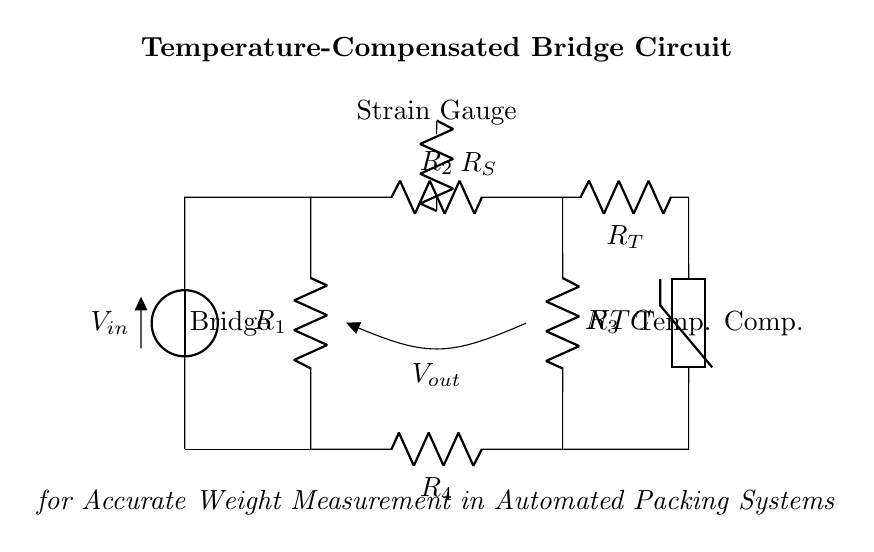What components are in the bridge circuit? The bridge circuit includes resistors R1, R2, R3, and R4, as well as a voltage source, a strain gauge, and a temperature compensation circuit with a thermistor (NTC).
Answer: R1, R2, R3, R4, voltage source, strain gauge, thermistor What type of strain measurement does this circuit utilize? The circuit utilizes a strain gauge for measuring mechanical strain. This component is specifically designed to detect changes in resistance due to applied mechanical stress, thus affecting the output voltage.
Answer: Strain gauge What is the purpose of the thermistor in the circuit? The thermistor is used for temperature compensation to ensure that the weight measurement remains accurate despite temperature variations, as changes in temperature can affect the resistance of the strain gauge.
Answer: Temperature compensation Which component connects to the output voltage? The output voltage is connected between the midpoints of the resistive bridge formed by R1, R2, R3, and R4, specifically where the strain gauge affects the bridge balance.
Answer: Strain gauge How does the temperature compensation circuit affect the measurement? The temperature compensation circuit adjusts the resistance of R_T and the thermistor in response to temperature changes, thereby stabilizing the bridge's output voltage and ensuring consistent weight measurements regardless of temperature fluctuations.
Answer: Stabilizes output What is the expected output voltage when the bridge is balanced? When the bridge is perfectly balanced, the output voltage V_out will be zero, indicating that there is no difference in potential across the output terminals.
Answer: Zero 